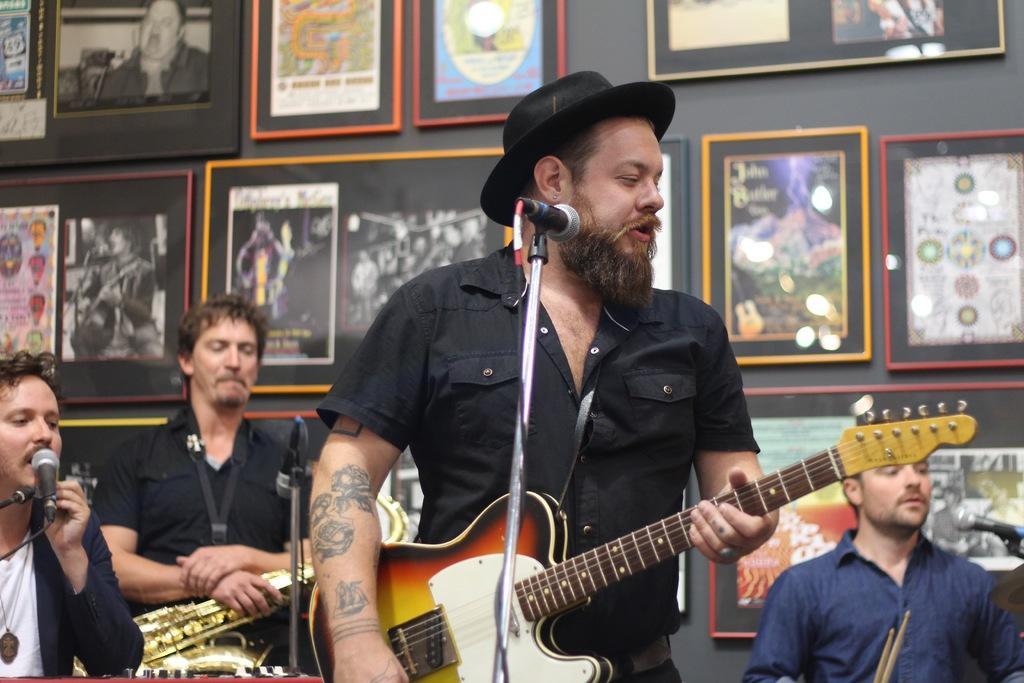In one or two sentences, can you explain what this image depicts? This image is clicked in a musical concert. There are four people in this image. three of them are wearing black shirt ,one who is on the right side bottom corner is wearing navy blue color shirt. A person who is standing in the middle is playing guitar. He has Mike in front of him. Everyone has Mike in front of them. All of them are using some musical instruments. There are photo frames behind them on the wall. 